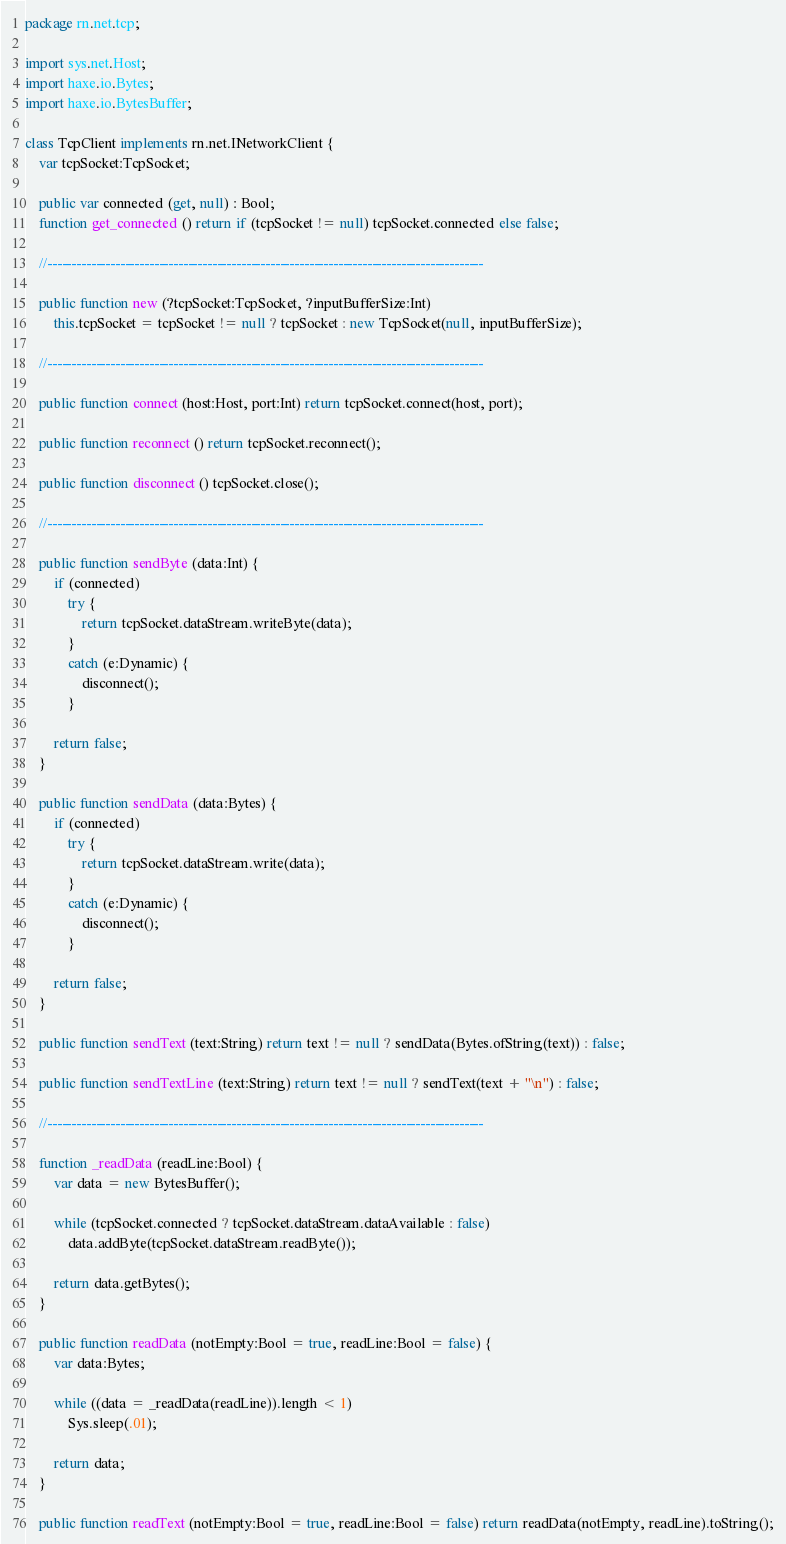Convert code to text. <code><loc_0><loc_0><loc_500><loc_500><_Haxe_>package rn.net.tcp;

import sys.net.Host;
import haxe.io.Bytes;
import haxe.io.BytesBuffer;

class TcpClient implements rn.net.INetworkClient {
	var tcpSocket:TcpSocket;
	
	public var connected (get, null) : Bool;
	function get_connected () return if (tcpSocket != null) tcpSocket.connected else false;
	
	//------------------------------------------------------------------------------------------
	
	public function new (?tcpSocket:TcpSocket, ?inputBufferSize:Int)
		this.tcpSocket = tcpSocket != null ? tcpSocket : new TcpSocket(null, inputBufferSize);
	
	//------------------------------------------------------------------------------------------
	
	public function connect (host:Host, port:Int) return tcpSocket.connect(host, port);
	
	public function reconnect () return tcpSocket.reconnect();
	
	public function disconnect () tcpSocket.close();
	
	//------------------------------------------------------------------------------------------
	
	public function sendByte (data:Int) {
		if (connected)
			try {
				return tcpSocket.dataStream.writeByte(data);
			}
			catch (e:Dynamic) {
				disconnect();
			}
		
		return false;
	}

	public function sendData (data:Bytes) {
		if (connected)
			try {
				return tcpSocket.dataStream.write(data);
			}
			catch (e:Dynamic) {
				disconnect();
			}
		
		return false;
	}

	public function sendText (text:String) return text != null ? sendData(Bytes.ofString(text)) : false;
	
	public function sendTextLine (text:String) return text != null ? sendText(text + "\n") : false;

	//------------------------------------------------------------------------------------------
	
	function _readData (readLine:Bool) {
		var data = new BytesBuffer();
		
		while (tcpSocket.connected ? tcpSocket.dataStream.dataAvailable : false)
			data.addByte(tcpSocket.dataStream.readByte());
		
		return data.getBytes();
	}

	public function readData (notEmpty:Bool = true, readLine:Bool = false) {
		var data:Bytes;

		while ((data = _readData(readLine)).length < 1)
			Sys.sleep(.01);
		
		return data;
	}
	
	public function readText (notEmpty:Bool = true, readLine:Bool = false) return readData(notEmpty, readLine).toString();</code> 